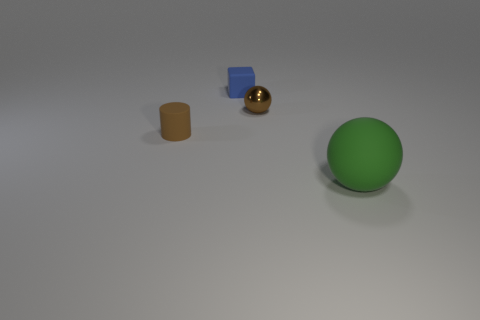Add 4 large blue rubber things. How many objects exist? 8 Subtract all cylinders. How many objects are left? 3 Subtract 0 red cylinders. How many objects are left? 4 Subtract all blue cylinders. Subtract all blue cubes. How many cylinders are left? 1 Subtract all cyan blocks. Subtract all small rubber blocks. How many objects are left? 3 Add 4 blue rubber blocks. How many blue rubber blocks are left? 5 Add 3 large brown objects. How many large brown objects exist? 3 